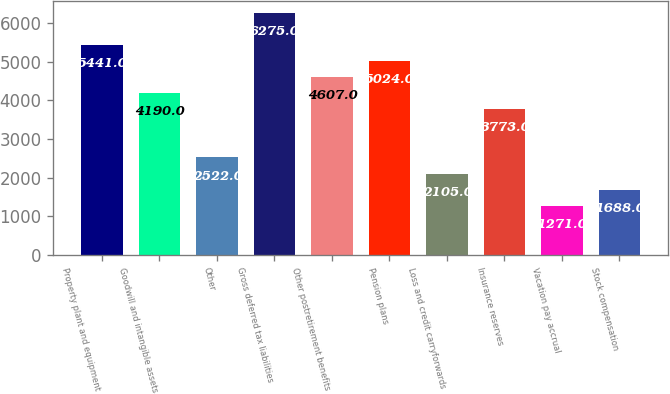<chart> <loc_0><loc_0><loc_500><loc_500><bar_chart><fcel>Property plant and equipment<fcel>Goodwill and intangible assets<fcel>Other<fcel>Gross deferred tax liabilities<fcel>Other postretirement benefits<fcel>Pension plans<fcel>Loss and credit carryforwards<fcel>Insurance reserves<fcel>Vacation pay accrual<fcel>Stock compensation<nl><fcel>5441<fcel>4190<fcel>2522<fcel>6275<fcel>4607<fcel>5024<fcel>2105<fcel>3773<fcel>1271<fcel>1688<nl></chart> 